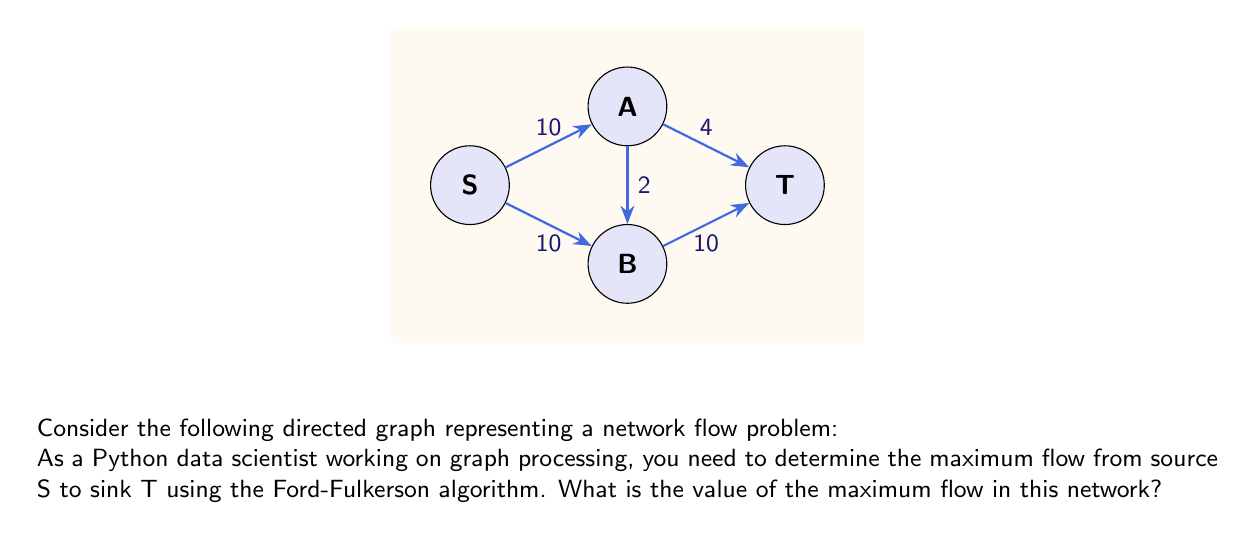Show me your answer to this math problem. To solve this problem using the Ford-Fulkerson algorithm, we'll follow these steps:

1) Initialize the flow to 0 for all edges.

2) Find an augmenting path from S to T:
   - Path 1: S -> A -> T (min capacity = 4)
   Flow becomes 4, residual graph updates.

3) Find another augmenting path:
   - Path 2: S -> B -> T (min capacity = 10)
   Flow becomes 4 + 10 = 14, residual graph updates.

4) Find another augmenting path:
   - Path 3: S -> A -> B -> T (min capacity = 2)
   Flow becomes 14 + 2 = 16, residual graph updates.

5) No more augmenting paths exist.

The Ford-Fulkerson algorithm terminates when no augmenting path can be found in the residual graph. At this point, the maximum flow has been achieved.

Let's verify the flow conservation:
- Flow out of S: 6 (to A) + 10 (to B) = 16
- Flow into T: 6 (from A) + 10 (from B) = 16

The flow is conserved at each node, and the total flow from S to T is 16.

In Python, you might implement this using a library like NetworkX:

```python
import networkx as nx

G = nx.DiGraph()
G.add_edge('S', 'A', capacity=10)
G.add_edge('S', 'B', capacity=10)
G.add_edge('A', 'B', capacity=2)
G.add_edge('A', 'T', capacity=4)
G.add_edge('B', 'T', capacity=10)

flow_value, flow_dict = nx.maximum_flow(G, 'S', 'T')
```

This would give you the maximum flow value and the flow on each edge.
Answer: 16 